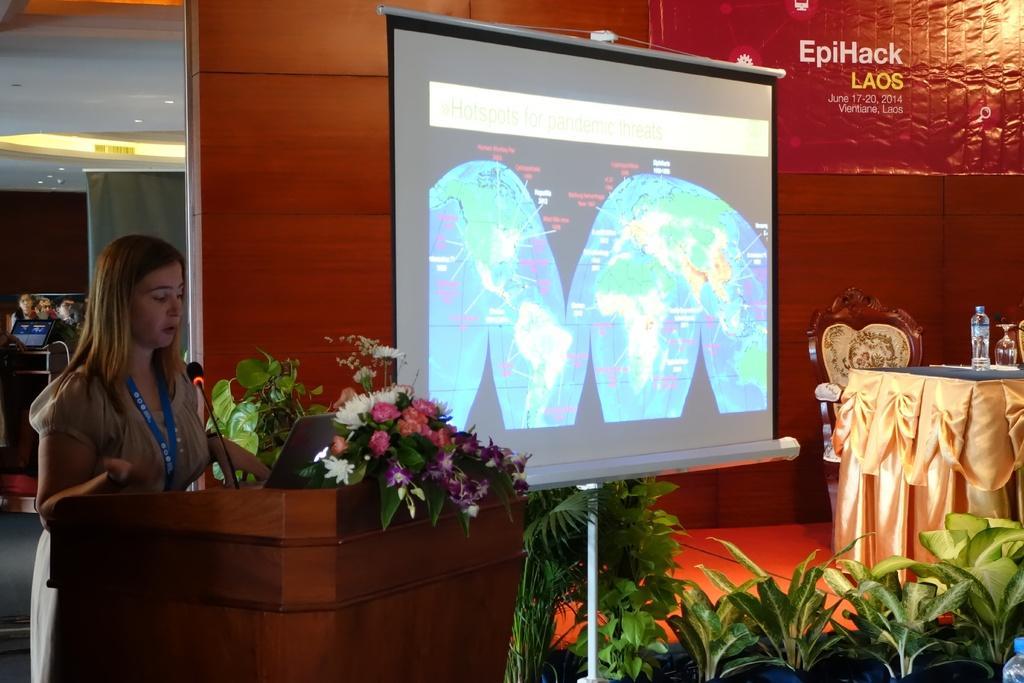Please provide a concise description of this image. In this image on the left side there is one woman standing, and in front of her there is podium. On the podium there is a laptop, mike and some flower bouquets and it seems that she is talking. In the center there is a screen and in the background there are some plants and table. On the table there is bottle glass and beside the table there is one chair, and in the background there is board and wall and some persons and some other objects. At the top there is ceiling and some lights. 